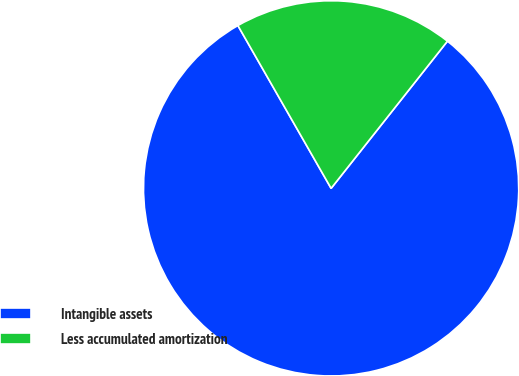Convert chart. <chart><loc_0><loc_0><loc_500><loc_500><pie_chart><fcel>Intangible assets<fcel>Less accumulated amortization<nl><fcel>81.08%<fcel>18.92%<nl></chart> 